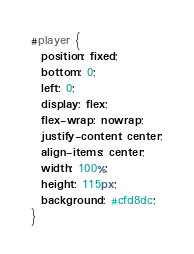Convert code to text. <code><loc_0><loc_0><loc_500><loc_500><_CSS_>#player {
  position: fixed;
  bottom: 0;
  left: 0;
  display: flex;
  flex-wrap: nowrap;
  justify-content: center;
  align-items: center;
  width: 100%;
  height: 115px;
  background: #cfd8dc;
}
</code> 